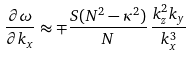Convert formula to latex. <formula><loc_0><loc_0><loc_500><loc_500>\frac { \partial \omega } { \partial k _ { x } } \approx \mp \frac { S ( N ^ { 2 } - \kappa ^ { 2 } ) } { N } \, \frac { k _ { z } ^ { 2 } k _ { y } } { k _ { x } ^ { 3 } }</formula> 